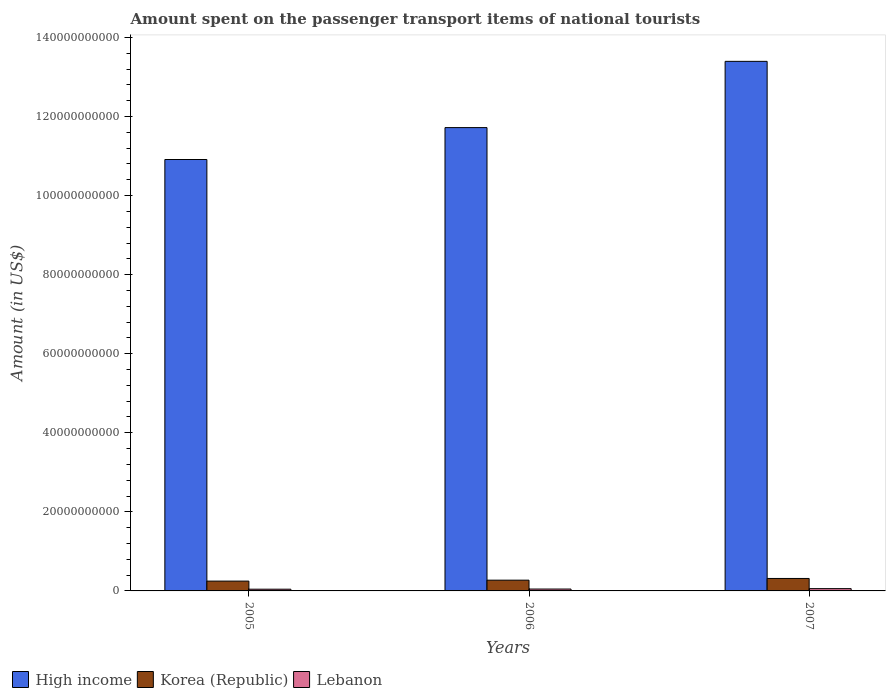Are the number of bars per tick equal to the number of legend labels?
Keep it short and to the point. Yes. Are the number of bars on each tick of the X-axis equal?
Ensure brevity in your answer.  Yes. How many bars are there on the 2nd tick from the left?
Keep it short and to the point. 3. How many bars are there on the 3rd tick from the right?
Make the answer very short. 3. What is the label of the 3rd group of bars from the left?
Make the answer very short. 2007. What is the amount spent on the passenger transport items of national tourists in Lebanon in 2007?
Your response must be concise. 5.80e+08. Across all years, what is the maximum amount spent on the passenger transport items of national tourists in Lebanon?
Make the answer very short. 5.80e+08. Across all years, what is the minimum amount spent on the passenger transport items of national tourists in Korea (Republic)?
Offer a very short reply. 2.48e+09. In which year was the amount spent on the passenger transport items of national tourists in Lebanon minimum?
Your answer should be very brief. 2005. What is the total amount spent on the passenger transport items of national tourists in High income in the graph?
Offer a very short reply. 3.60e+11. What is the difference between the amount spent on the passenger transport items of national tourists in Korea (Republic) in 2006 and that in 2007?
Provide a succinct answer. -4.30e+08. What is the difference between the amount spent on the passenger transport items of national tourists in Lebanon in 2007 and the amount spent on the passenger transport items of national tourists in High income in 2006?
Your answer should be very brief. -1.17e+11. What is the average amount spent on the passenger transport items of national tourists in Korea (Republic) per year?
Your answer should be compact. 2.78e+09. In the year 2007, what is the difference between the amount spent on the passenger transport items of national tourists in High income and amount spent on the passenger transport items of national tourists in Lebanon?
Ensure brevity in your answer.  1.33e+11. In how many years, is the amount spent on the passenger transport items of national tourists in High income greater than 12000000000 US$?
Give a very brief answer. 3. What is the ratio of the amount spent on the passenger transport items of national tourists in Korea (Republic) in 2005 to that in 2007?
Make the answer very short. 0.79. What is the difference between the highest and the second highest amount spent on the passenger transport items of national tourists in Lebanon?
Ensure brevity in your answer.  1.04e+08. What is the difference between the highest and the lowest amount spent on the passenger transport items of national tourists in Lebanon?
Make the answer very short. 1.43e+08. Is the sum of the amount spent on the passenger transport items of national tourists in High income in 2006 and 2007 greater than the maximum amount spent on the passenger transport items of national tourists in Korea (Republic) across all years?
Provide a short and direct response. Yes. What does the 3rd bar from the left in 2006 represents?
Offer a terse response. Lebanon. What does the 3rd bar from the right in 2006 represents?
Your answer should be compact. High income. How many bars are there?
Make the answer very short. 9. Are all the bars in the graph horizontal?
Provide a short and direct response. No. Does the graph contain any zero values?
Provide a succinct answer. No. What is the title of the graph?
Ensure brevity in your answer.  Amount spent on the passenger transport items of national tourists. What is the label or title of the Y-axis?
Your response must be concise. Amount (in US$). What is the Amount (in US$) in High income in 2005?
Your answer should be very brief. 1.09e+11. What is the Amount (in US$) in Korea (Republic) in 2005?
Make the answer very short. 2.48e+09. What is the Amount (in US$) in Lebanon in 2005?
Keep it short and to the point. 4.37e+08. What is the Amount (in US$) in High income in 2006?
Provide a succinct answer. 1.17e+11. What is the Amount (in US$) in Korea (Republic) in 2006?
Your response must be concise. 2.72e+09. What is the Amount (in US$) in Lebanon in 2006?
Your answer should be very brief. 4.76e+08. What is the Amount (in US$) in High income in 2007?
Offer a very short reply. 1.34e+11. What is the Amount (in US$) of Korea (Republic) in 2007?
Offer a terse response. 3.15e+09. What is the Amount (in US$) in Lebanon in 2007?
Offer a terse response. 5.80e+08. Across all years, what is the maximum Amount (in US$) in High income?
Your response must be concise. 1.34e+11. Across all years, what is the maximum Amount (in US$) of Korea (Republic)?
Your answer should be very brief. 3.15e+09. Across all years, what is the maximum Amount (in US$) in Lebanon?
Your answer should be very brief. 5.80e+08. Across all years, what is the minimum Amount (in US$) of High income?
Your answer should be compact. 1.09e+11. Across all years, what is the minimum Amount (in US$) in Korea (Republic)?
Ensure brevity in your answer.  2.48e+09. Across all years, what is the minimum Amount (in US$) of Lebanon?
Offer a terse response. 4.37e+08. What is the total Amount (in US$) in High income in the graph?
Offer a very short reply. 3.60e+11. What is the total Amount (in US$) of Korea (Republic) in the graph?
Offer a terse response. 8.35e+09. What is the total Amount (in US$) in Lebanon in the graph?
Offer a terse response. 1.49e+09. What is the difference between the Amount (in US$) of High income in 2005 and that in 2006?
Give a very brief answer. -8.07e+09. What is the difference between the Amount (in US$) in Korea (Republic) in 2005 and that in 2006?
Offer a very short reply. -2.36e+08. What is the difference between the Amount (in US$) in Lebanon in 2005 and that in 2006?
Keep it short and to the point. -3.90e+07. What is the difference between the Amount (in US$) in High income in 2005 and that in 2007?
Make the answer very short. -2.48e+1. What is the difference between the Amount (in US$) in Korea (Republic) in 2005 and that in 2007?
Provide a short and direct response. -6.66e+08. What is the difference between the Amount (in US$) of Lebanon in 2005 and that in 2007?
Keep it short and to the point. -1.43e+08. What is the difference between the Amount (in US$) in High income in 2006 and that in 2007?
Provide a short and direct response. -1.68e+1. What is the difference between the Amount (in US$) in Korea (Republic) in 2006 and that in 2007?
Provide a short and direct response. -4.30e+08. What is the difference between the Amount (in US$) in Lebanon in 2006 and that in 2007?
Offer a very short reply. -1.04e+08. What is the difference between the Amount (in US$) of High income in 2005 and the Amount (in US$) of Korea (Republic) in 2006?
Ensure brevity in your answer.  1.06e+11. What is the difference between the Amount (in US$) of High income in 2005 and the Amount (in US$) of Lebanon in 2006?
Provide a short and direct response. 1.09e+11. What is the difference between the Amount (in US$) of Korea (Republic) in 2005 and the Amount (in US$) of Lebanon in 2006?
Make the answer very short. 2.01e+09. What is the difference between the Amount (in US$) of High income in 2005 and the Amount (in US$) of Korea (Republic) in 2007?
Provide a short and direct response. 1.06e+11. What is the difference between the Amount (in US$) of High income in 2005 and the Amount (in US$) of Lebanon in 2007?
Give a very brief answer. 1.09e+11. What is the difference between the Amount (in US$) of Korea (Republic) in 2005 and the Amount (in US$) of Lebanon in 2007?
Make the answer very short. 1.90e+09. What is the difference between the Amount (in US$) in High income in 2006 and the Amount (in US$) in Korea (Republic) in 2007?
Offer a terse response. 1.14e+11. What is the difference between the Amount (in US$) in High income in 2006 and the Amount (in US$) in Lebanon in 2007?
Your answer should be very brief. 1.17e+11. What is the difference between the Amount (in US$) in Korea (Republic) in 2006 and the Amount (in US$) in Lebanon in 2007?
Provide a short and direct response. 2.14e+09. What is the average Amount (in US$) of High income per year?
Offer a terse response. 1.20e+11. What is the average Amount (in US$) of Korea (Republic) per year?
Give a very brief answer. 2.78e+09. What is the average Amount (in US$) in Lebanon per year?
Your answer should be very brief. 4.98e+08. In the year 2005, what is the difference between the Amount (in US$) of High income and Amount (in US$) of Korea (Republic)?
Your response must be concise. 1.07e+11. In the year 2005, what is the difference between the Amount (in US$) of High income and Amount (in US$) of Lebanon?
Your answer should be compact. 1.09e+11. In the year 2005, what is the difference between the Amount (in US$) of Korea (Republic) and Amount (in US$) of Lebanon?
Make the answer very short. 2.05e+09. In the year 2006, what is the difference between the Amount (in US$) in High income and Amount (in US$) in Korea (Republic)?
Make the answer very short. 1.14e+11. In the year 2006, what is the difference between the Amount (in US$) of High income and Amount (in US$) of Lebanon?
Make the answer very short. 1.17e+11. In the year 2006, what is the difference between the Amount (in US$) in Korea (Republic) and Amount (in US$) in Lebanon?
Make the answer very short. 2.24e+09. In the year 2007, what is the difference between the Amount (in US$) in High income and Amount (in US$) in Korea (Republic)?
Give a very brief answer. 1.31e+11. In the year 2007, what is the difference between the Amount (in US$) of High income and Amount (in US$) of Lebanon?
Offer a terse response. 1.33e+11. In the year 2007, what is the difference between the Amount (in US$) in Korea (Republic) and Amount (in US$) in Lebanon?
Offer a terse response. 2.57e+09. What is the ratio of the Amount (in US$) in High income in 2005 to that in 2006?
Your answer should be very brief. 0.93. What is the ratio of the Amount (in US$) of Korea (Republic) in 2005 to that in 2006?
Make the answer very short. 0.91. What is the ratio of the Amount (in US$) in Lebanon in 2005 to that in 2006?
Provide a short and direct response. 0.92. What is the ratio of the Amount (in US$) in High income in 2005 to that in 2007?
Ensure brevity in your answer.  0.81. What is the ratio of the Amount (in US$) of Korea (Republic) in 2005 to that in 2007?
Provide a short and direct response. 0.79. What is the ratio of the Amount (in US$) of Lebanon in 2005 to that in 2007?
Offer a very short reply. 0.75. What is the ratio of the Amount (in US$) of High income in 2006 to that in 2007?
Provide a succinct answer. 0.87. What is the ratio of the Amount (in US$) of Korea (Republic) in 2006 to that in 2007?
Your answer should be very brief. 0.86. What is the ratio of the Amount (in US$) in Lebanon in 2006 to that in 2007?
Give a very brief answer. 0.82. What is the difference between the highest and the second highest Amount (in US$) in High income?
Your answer should be compact. 1.68e+1. What is the difference between the highest and the second highest Amount (in US$) of Korea (Republic)?
Your response must be concise. 4.30e+08. What is the difference between the highest and the second highest Amount (in US$) in Lebanon?
Give a very brief answer. 1.04e+08. What is the difference between the highest and the lowest Amount (in US$) in High income?
Your response must be concise. 2.48e+1. What is the difference between the highest and the lowest Amount (in US$) in Korea (Republic)?
Ensure brevity in your answer.  6.66e+08. What is the difference between the highest and the lowest Amount (in US$) of Lebanon?
Make the answer very short. 1.43e+08. 